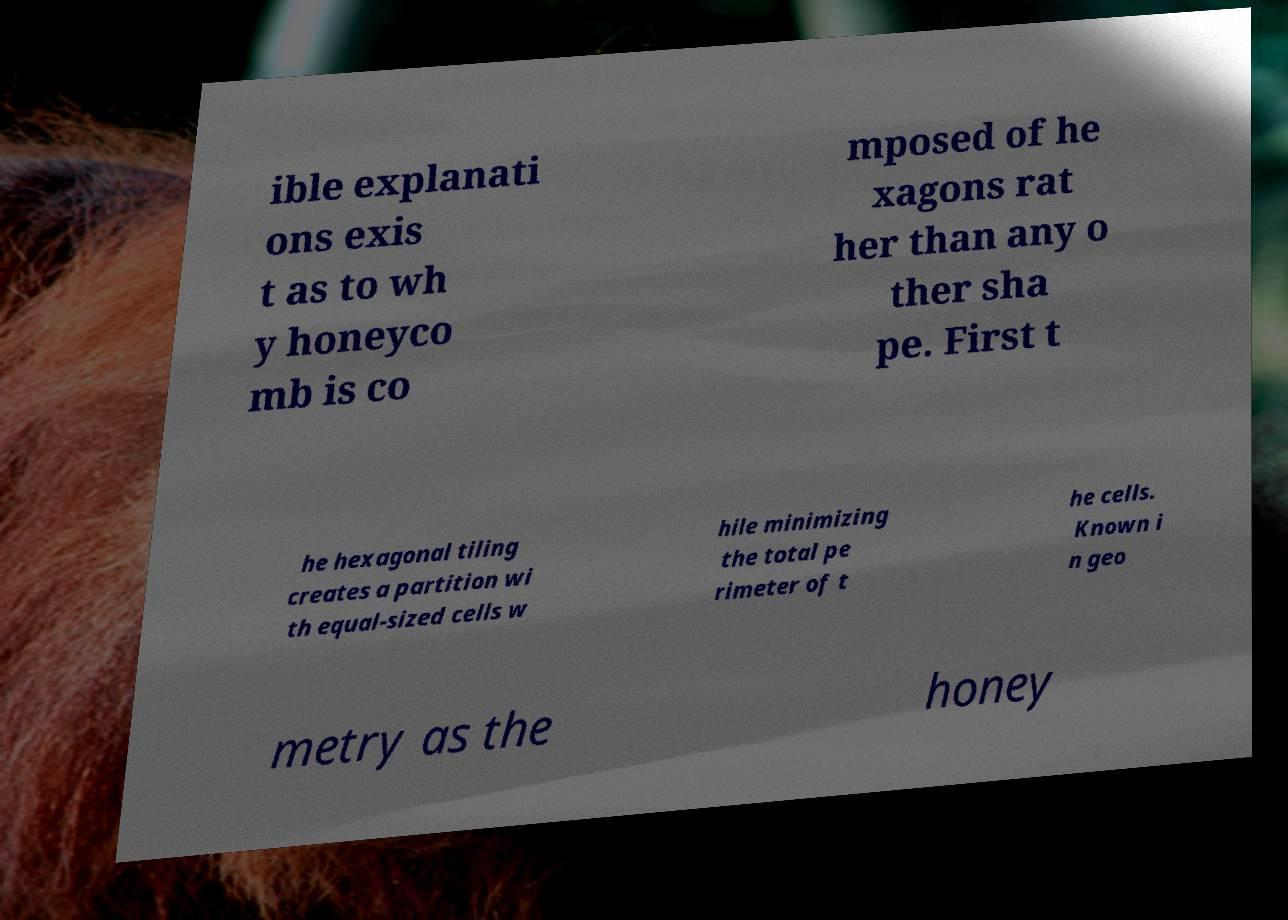Could you assist in decoding the text presented in this image and type it out clearly? ible explanati ons exis t as to wh y honeyco mb is co mposed of he xagons rat her than any o ther sha pe. First t he hexagonal tiling creates a partition wi th equal-sized cells w hile minimizing the total pe rimeter of t he cells. Known i n geo metry as the honey 